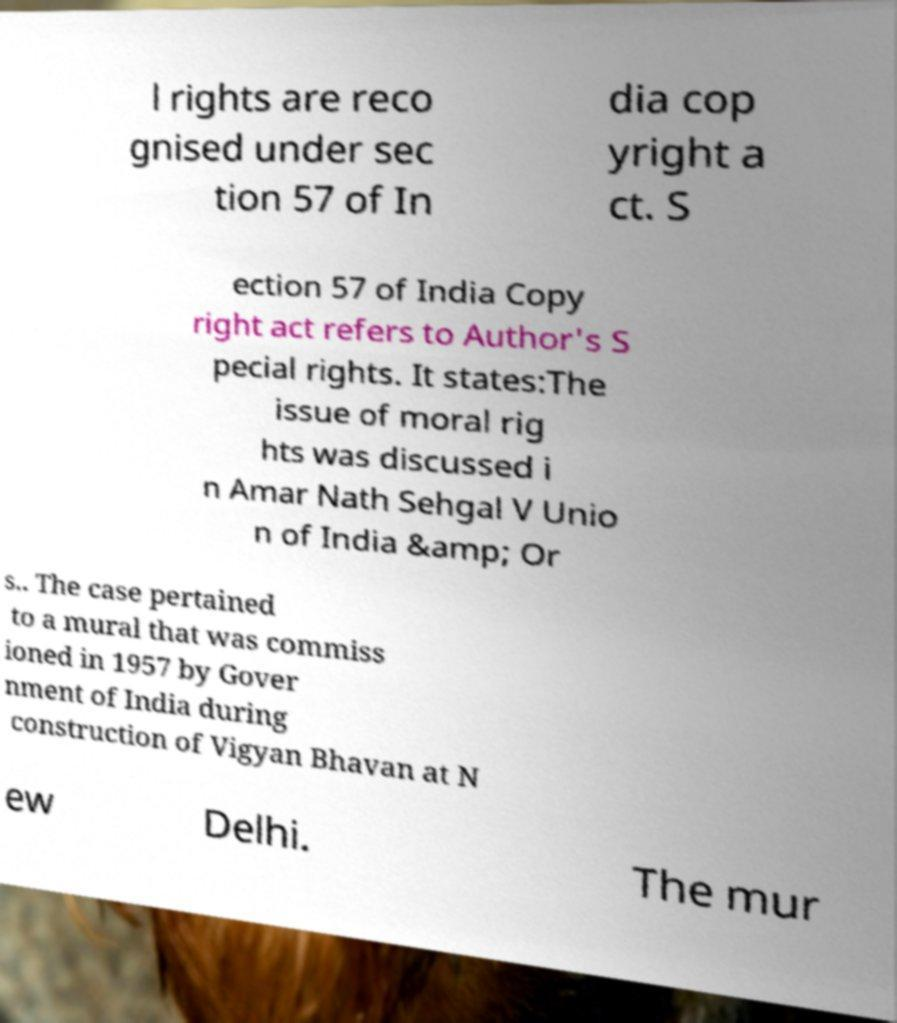Can you read and provide the text displayed in the image?This photo seems to have some interesting text. Can you extract and type it out for me? l rights are reco gnised under sec tion 57 of In dia cop yright a ct. S ection 57 of India Copy right act refers to Author's S pecial rights. It states:The issue of moral rig hts was discussed i n Amar Nath Sehgal V Unio n of India &amp; Or s.. The case pertained to a mural that was commiss ioned in 1957 by Gover nment of India during construction of Vigyan Bhavan at N ew Delhi. The mur 